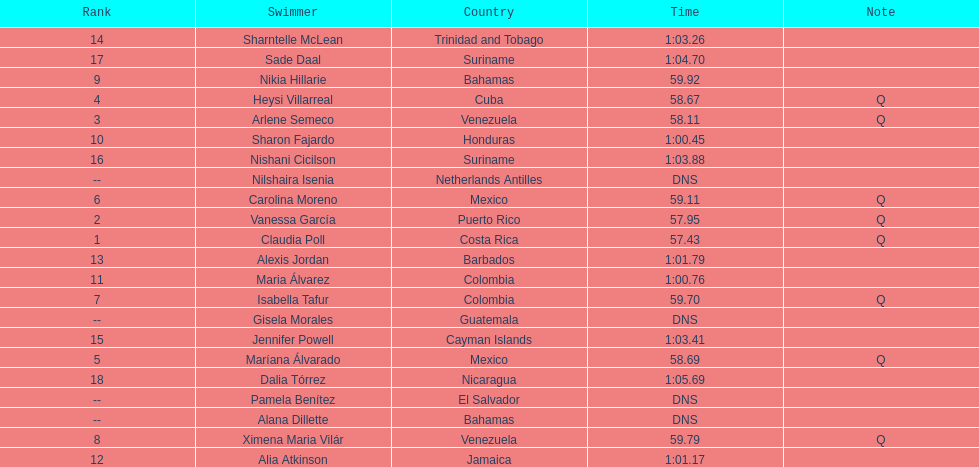Could you parse the entire table? {'header': ['Rank', 'Swimmer', 'Country', 'Time', 'Note'], 'rows': [['14', 'Sharntelle McLean', 'Trinidad and Tobago', '1:03.26', ''], ['17', 'Sade Daal', 'Suriname', '1:04.70', ''], ['9', 'Nikia Hillarie', 'Bahamas', '59.92', ''], ['4', 'Heysi Villarreal', 'Cuba', '58.67', 'Q'], ['3', 'Arlene Semeco', 'Venezuela', '58.11', 'Q'], ['10', 'Sharon Fajardo', 'Honduras', '1:00.45', ''], ['16', 'Nishani Cicilson', 'Suriname', '1:03.88', ''], ['--', 'Nilshaira Isenia', 'Netherlands Antilles', 'DNS', ''], ['6', 'Carolina Moreno', 'Mexico', '59.11', 'Q'], ['2', 'Vanessa García', 'Puerto Rico', '57.95', 'Q'], ['1', 'Claudia Poll', 'Costa Rica', '57.43', 'Q'], ['13', 'Alexis Jordan', 'Barbados', '1:01.79', ''], ['11', 'Maria Álvarez', 'Colombia', '1:00.76', ''], ['7', 'Isabella Tafur', 'Colombia', '59.70', 'Q'], ['--', 'Gisela Morales', 'Guatemala', 'DNS', ''], ['15', 'Jennifer Powell', 'Cayman Islands', '1:03.41', ''], ['5', 'Maríana Álvarado', 'Mexico', '58.69', 'Q'], ['18', 'Dalia Tórrez', 'Nicaragua', '1:05.69', ''], ['--', 'Pamela Benítez', 'El Salvador', 'DNS', ''], ['--', 'Alana Dillette', 'Bahamas', 'DNS', ''], ['8', 'Ximena Maria Vilár', 'Venezuela', '59.79', 'Q'], ['12', 'Alia Atkinson', 'Jamaica', '1:01.17', '']]} Who was the only cuban to finish in the top eight? Heysi Villarreal. 